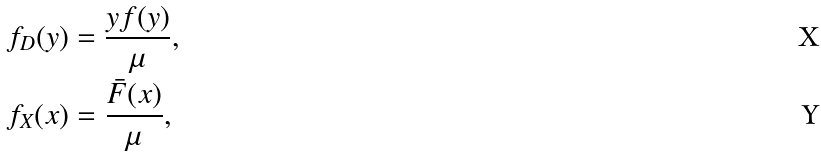<formula> <loc_0><loc_0><loc_500><loc_500>& f _ { D } ( y ) = \frac { y f ( y ) } { \mu } , \\ & f _ { X } ( x ) = \frac { { \bar { F } } ( x ) } { \mu } ,</formula> 